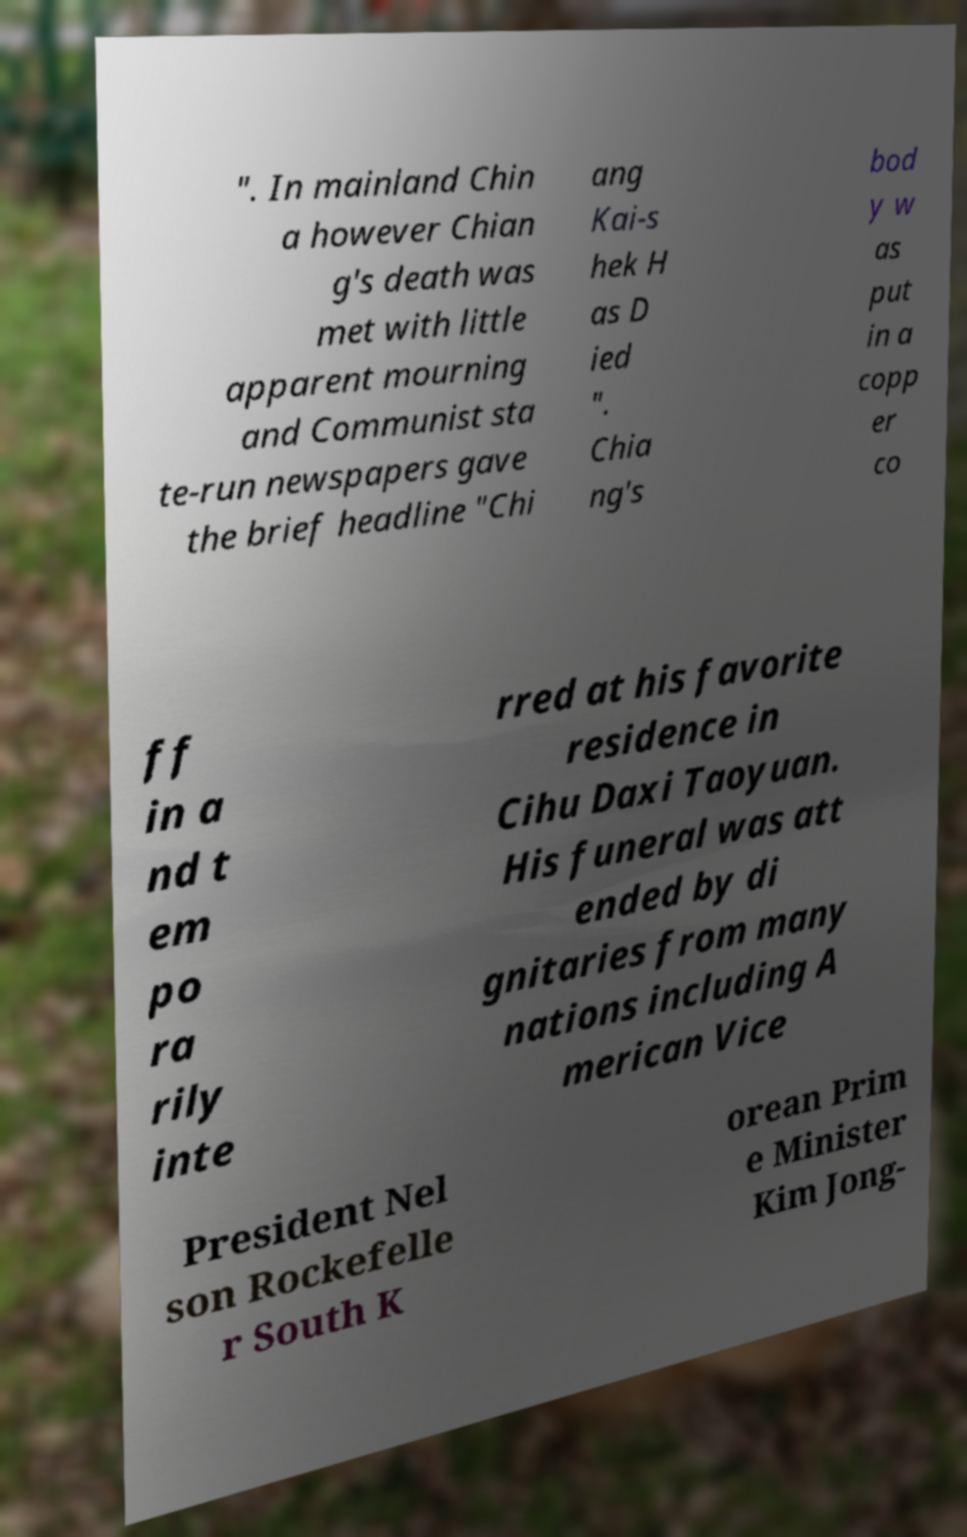For documentation purposes, I need the text within this image transcribed. Could you provide that? ". In mainland Chin a however Chian g's death was met with little apparent mourning and Communist sta te-run newspapers gave the brief headline "Chi ang Kai-s hek H as D ied ". Chia ng's bod y w as put in a copp er co ff in a nd t em po ra rily inte rred at his favorite residence in Cihu Daxi Taoyuan. His funeral was att ended by di gnitaries from many nations including A merican Vice President Nel son Rockefelle r South K orean Prim e Minister Kim Jong- 